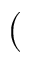<formula> <loc_0><loc_0><loc_500><loc_500>(</formula> 